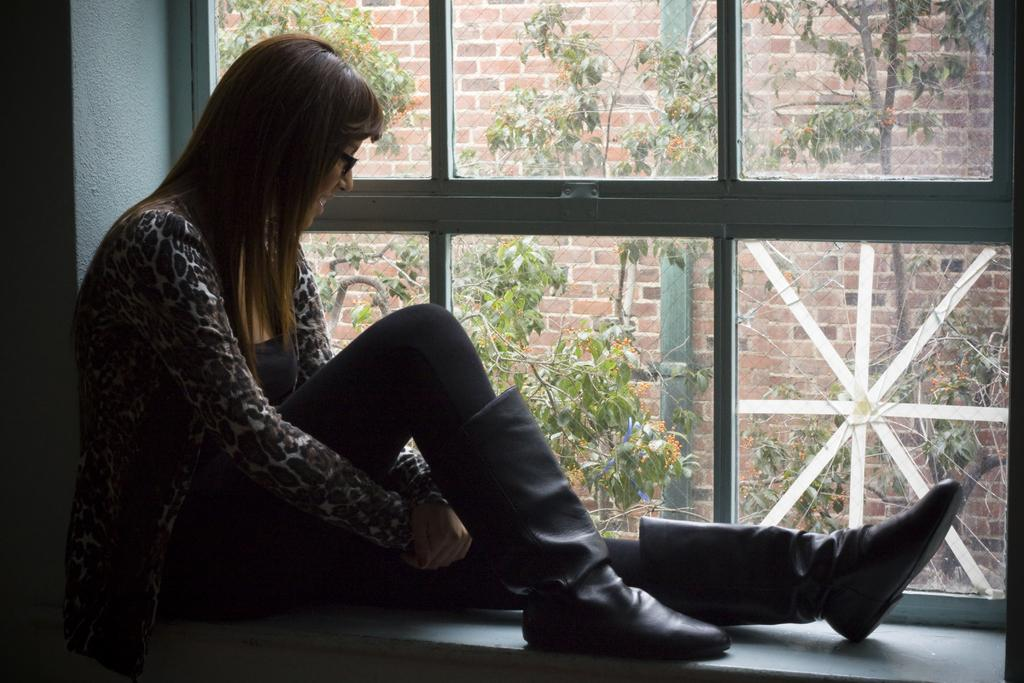What type of vegetation can be seen in the image? There are trees in the image. Who is present in the image? There is a woman in the image. What is the woman wearing? The woman is wearing a black dress and black boots. What architectural feature can be seen in the image? There is a wall in the image. What can be seen through the window in the image? There is a building visible outside the window. Where is the middle of the cows located in the image? There are no cows present in the image, so it is not possible to determine the location of their middle. What type of office furniture can be seen in the image? There is no office furniture present in the image. 